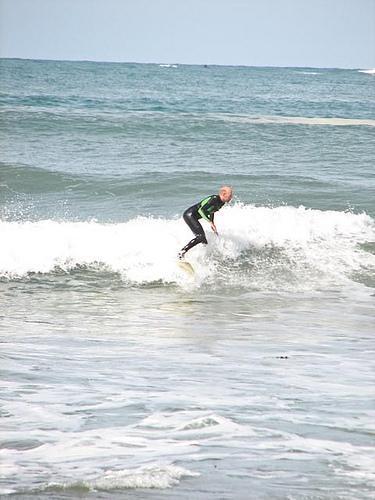How many people are in the scene?
Give a very brief answer. 1. 